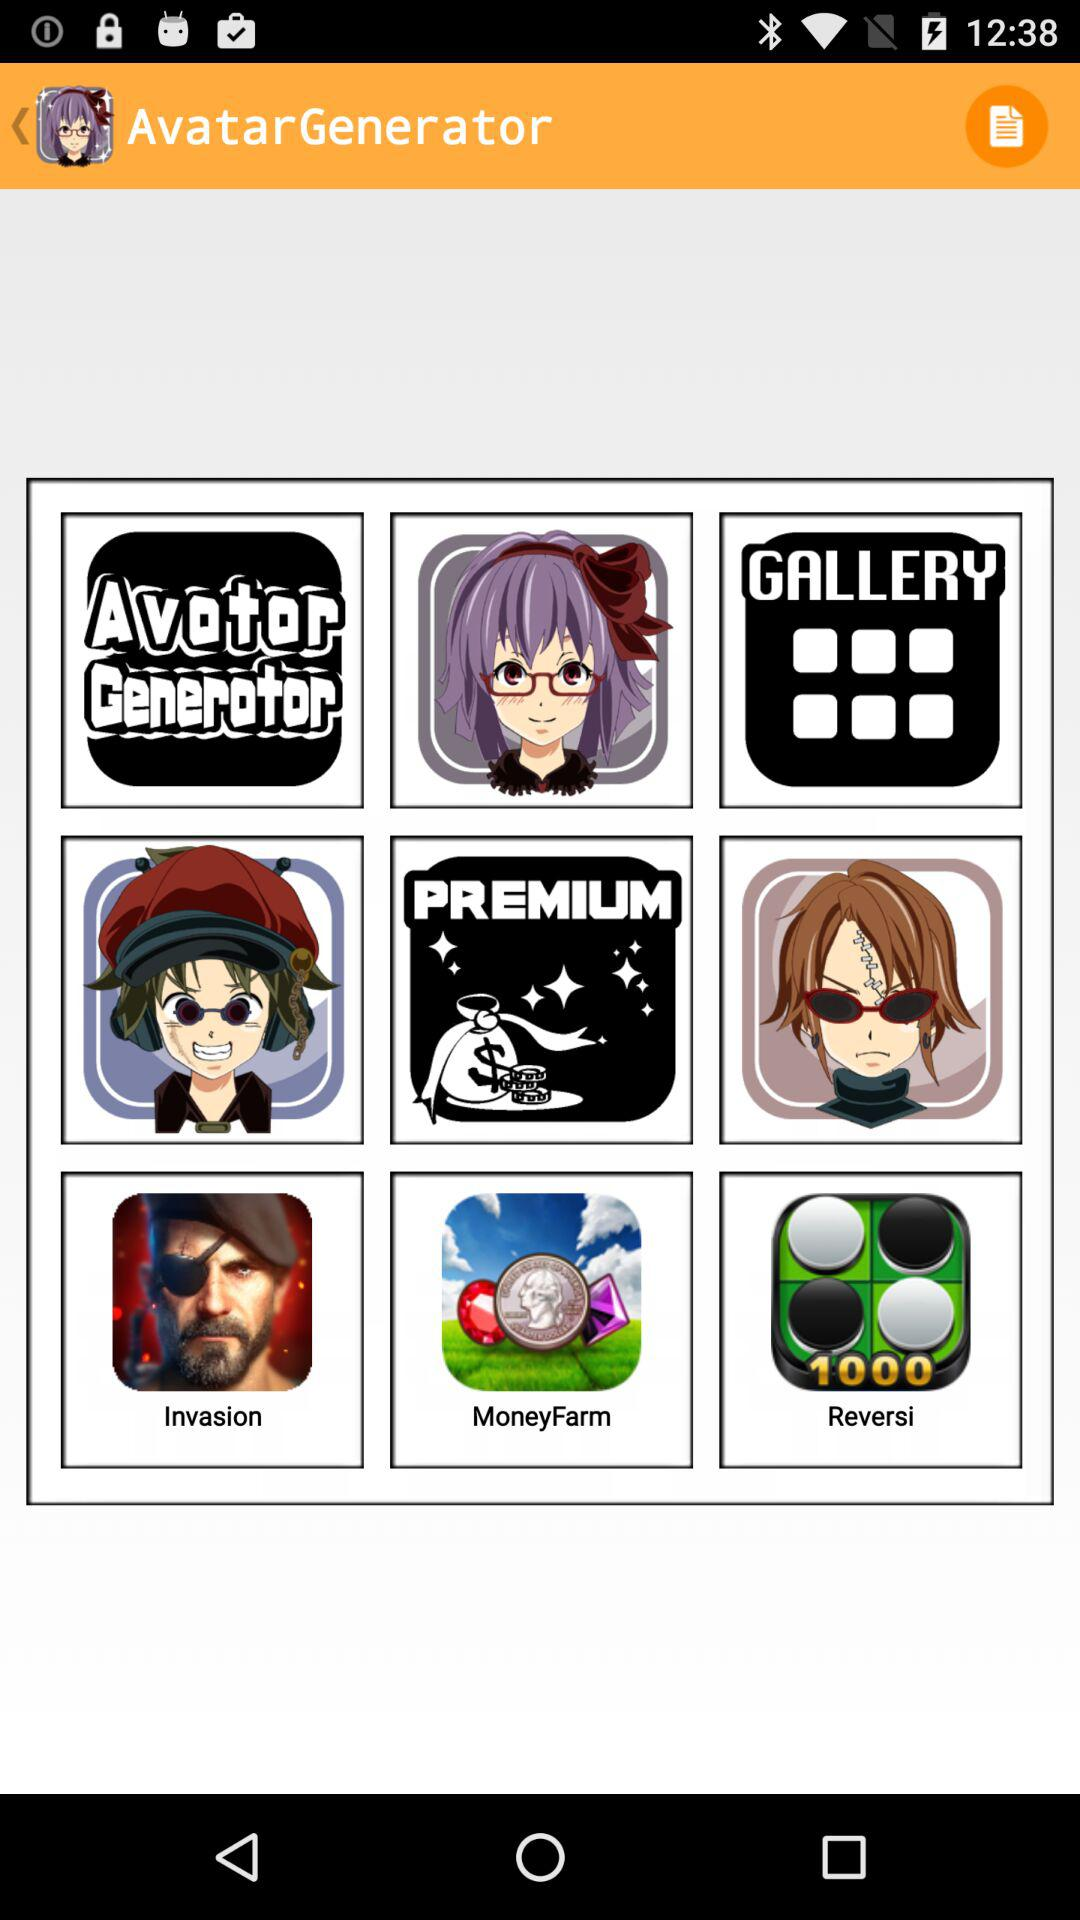How much does "MoneyFarm" cost?
When the provided information is insufficient, respond with <no answer>. <no answer> 